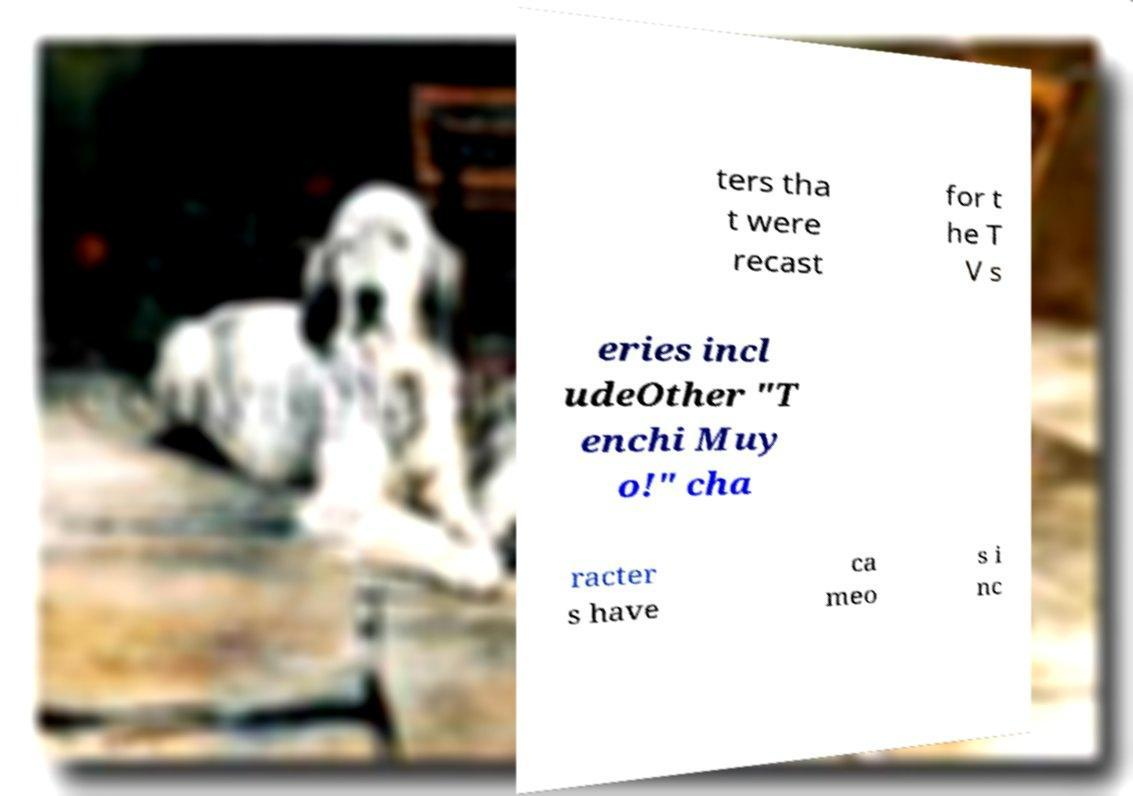Can you accurately transcribe the text from the provided image for me? ters tha t were recast for t he T V s eries incl udeOther "T enchi Muy o!" cha racter s have ca meo s i nc 